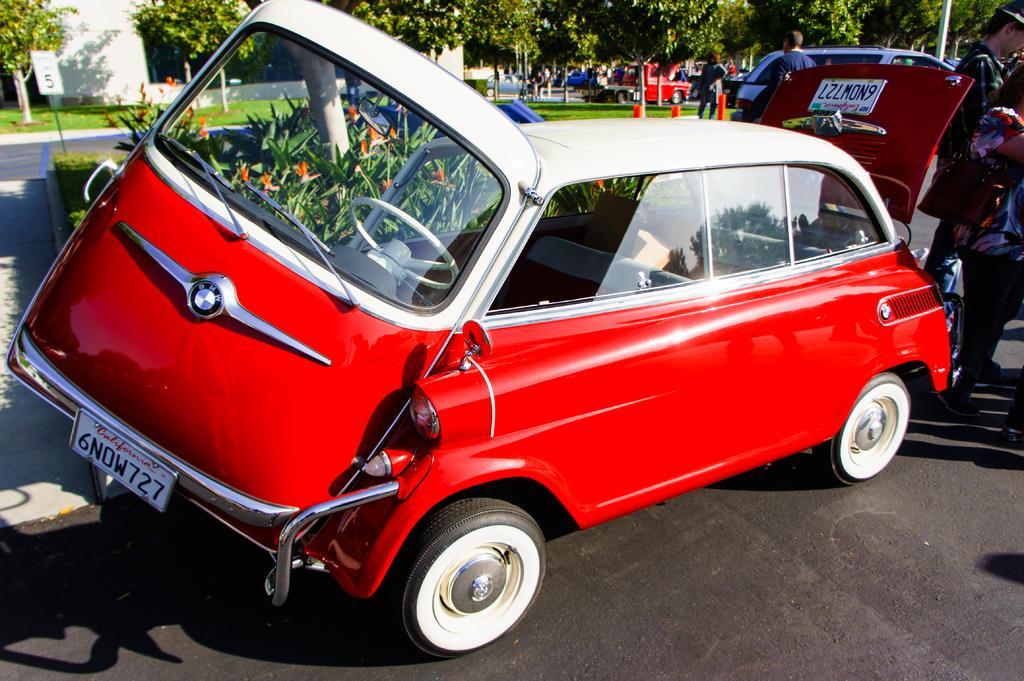In one or two sentences, can you explain what this image depicts? In this image there are some vehicles on the road beside that there are some people standing also there are some trees and building. 